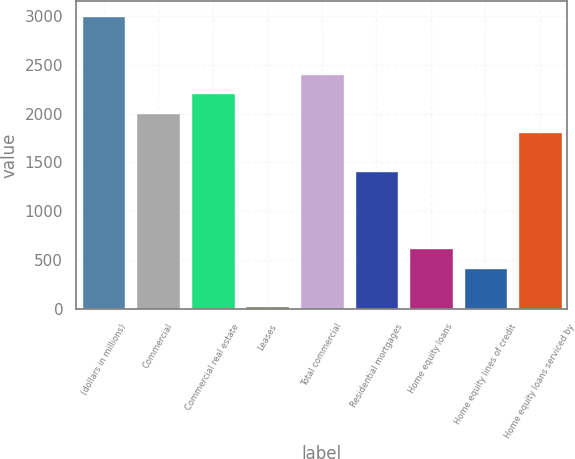Convert chart to OTSL. <chart><loc_0><loc_0><loc_500><loc_500><bar_chart><fcel>(dollars in millions)<fcel>Commercial<fcel>Commercial real estate<fcel>Leases<fcel>Total commercial<fcel>Residential mortgages<fcel>Home equity loans<fcel>Home equity lines of credit<fcel>Home equity loans serviced by<nl><fcel>3002.5<fcel>2011<fcel>2209.3<fcel>28<fcel>2407.6<fcel>1416.1<fcel>622.9<fcel>424.6<fcel>1812.7<nl></chart> 